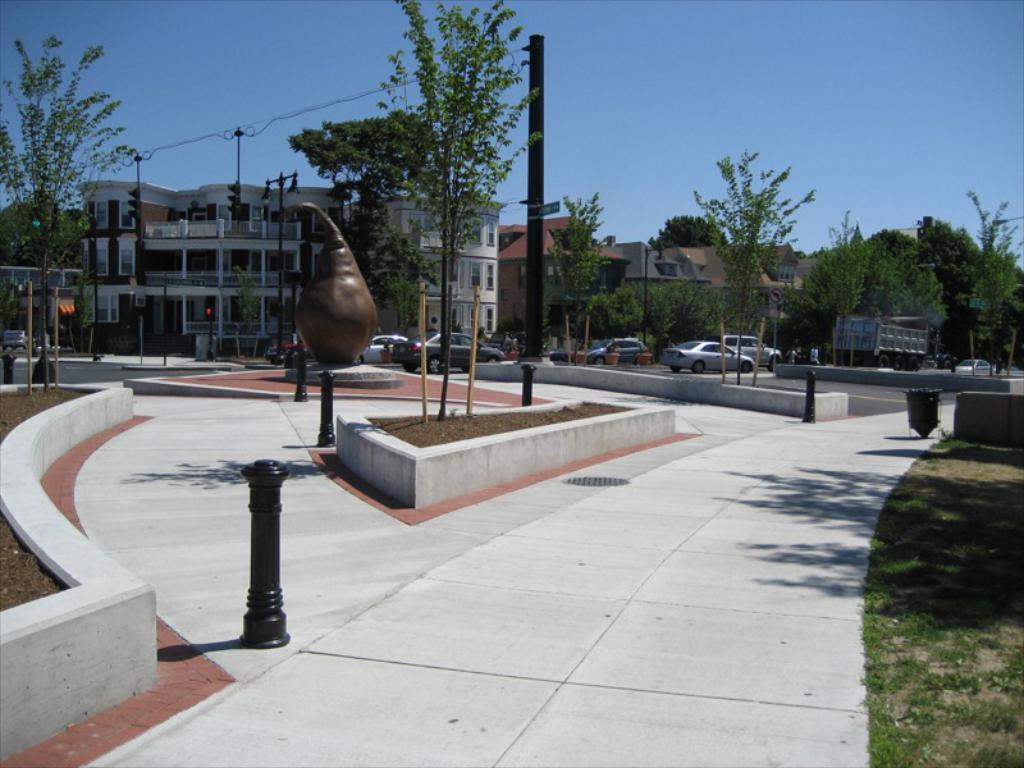Please provide a concise description of this image. In this image there is the sky towards the top of the image, there are buildings, there are poles, there is a wire, there are trees, there is the road, there are vehicles on the road, there is the grass towards the right of the image, there is a dustbin on the ground. 